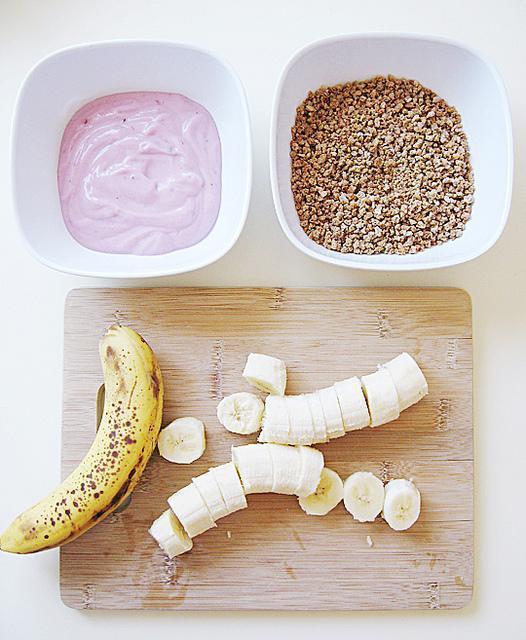How many bowls have toppings?
Give a very brief answer. 2. How many bananas are there?
Give a very brief answer. 6. How many bowls can you see?
Give a very brief answer. 2. 